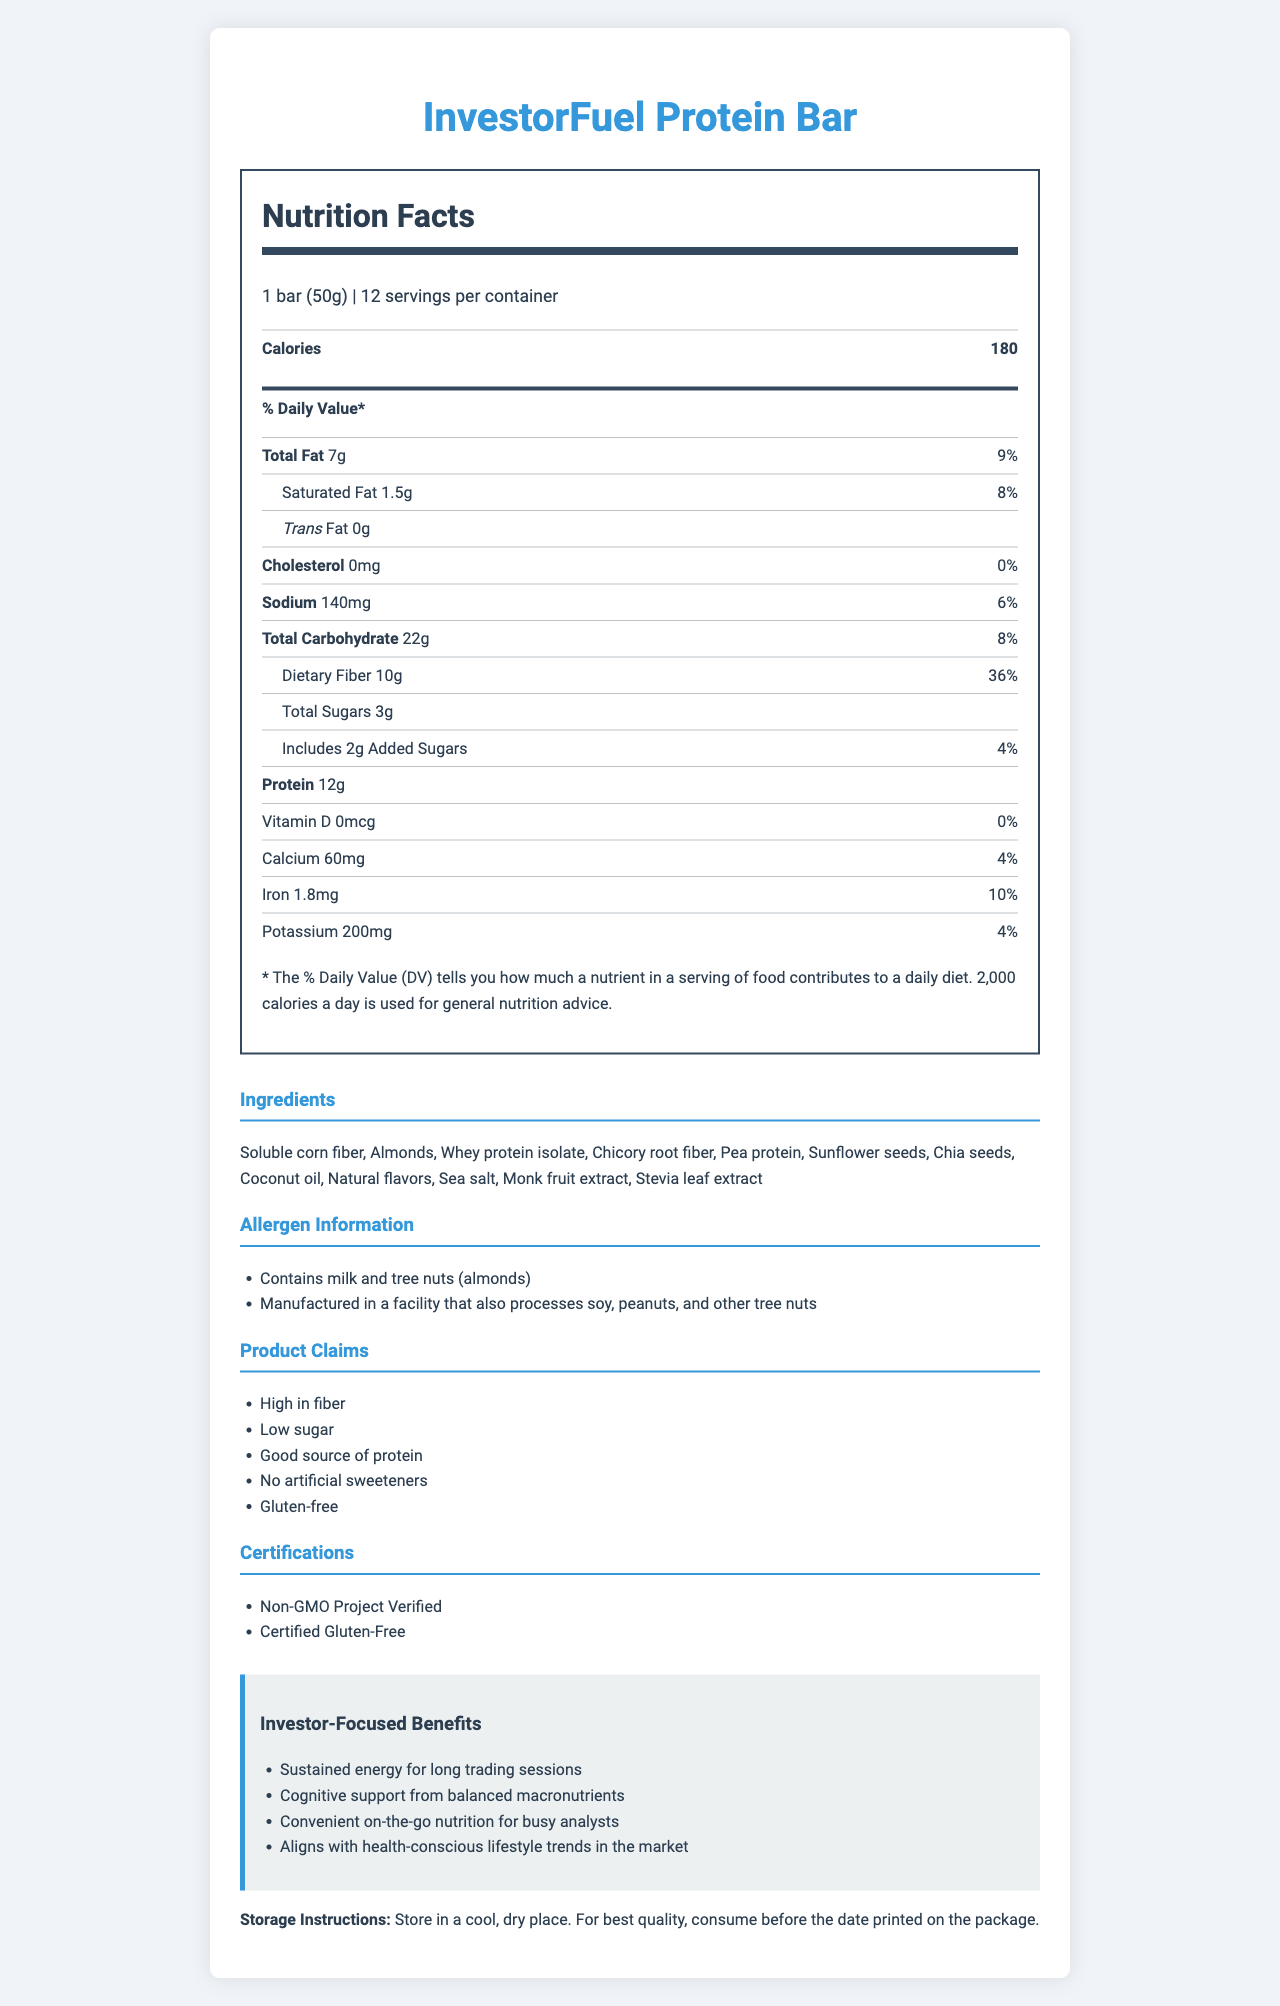what is the serving size of the InvestorFuel Protein Bar? The serving size is clearly stated on the nutrition label as "1 bar (50g)".
Answer: 1 bar (50g) how many servings are there per container? The label indicates there are 12 servings per container.
Answer: 12 what is the total amount of dietary fiber per serving? The total amount of dietary fiber per serving is listed as "10g" on the label.
Answer: 10g what percentage of the daily value is the protein content? The protein content is 12g, but the label does not provide a % daily value for it.
Answer: No percentage listed what is the total fat content of the snack bar? The total fat content is listed as "7g".
Answer: 7g does the InvestorFuel Protein Bar contain any trans fat? The document indicates that the trans fat amount is "0g".
Answer: No what are the main ingredients in the InvestorFuel Protein Bar? The ingredients list provides a detailed breakdown of all the components used in the bar.
Answer: Soluble corn fiber, Almonds, Whey protein isolate, Chicory root fiber, Pea protein, Sunflower seeds, Chia seeds, Coconut oil, Natural flavors, Sea salt, Monk fruit extract, Stevia leaf extract what allergens are present in the InvestorFuel Protein Bar? The allergen information section lists milk and tree nuts (almonds), and mentions that it is manufactured in a facility processing soy, peanuts, and other tree nuts.
Answer: Contains milk and tree nuts (almonds). Manufactured in a facility that also processes soy, peanuts, and other tree nuts How many calories does a serving of InvestorFuel Protein Bar offer? The calories per serving are clearly listed as 180.
Answer: 180 what is the percentage daily value of saturated fat in the bar? The amount of saturated fat daily value is shown to be "8%".
Answer: 8% which of the following marketing claims is not made about the InvestorFuel Protein Bar? A. Low sugar B. High in fiber C. Includes artificial sweeteners D. Gluten-free The document claims "No artificial sweeteners" indicating claim C is not made.
Answer: C which certification does the InvestorFuel Protein Bar have? I. Certified Organic II. Certified Gluten-Free III. Non-GMO Project Verified The text indicates that the bar is both Certified Gluten-Free and Non-GMO Project Verified.
Answer: II and III is the product suitable for someone avoiding gluten? The product is marked as "Certified Gluten-Free".
Answer: Yes does the InvestorFuel Protein Bar contain artificial sweeteners? The claims section emphasizes that the bar has "No artificial sweeteners".
Answer: No summarize the entire document. The document provides comprehensive information about the InvestorFuel Protein Bar, including its nutritional benefits, targeted claims, and investor-focused advantages. It emphasizes the product's alignment with health-conscious lifestyles and includes practical details for potential consumers and investors.
Answer: The document details the nutrition facts, ingredients, allergen information, marketing claims, certifications, and storage instructions for the InvestorFuel Protein Bar. It's aimed at health-conscious investors and highlights its high fiber, low sugar content, good protein source attributes, along with being gluten-free and non-GMO. what is the exact sales figure of the InvestorFuel Protein Bar last quarter? The document does not provide any sales figures or financial data related to the product.
Answer: Not enough information 